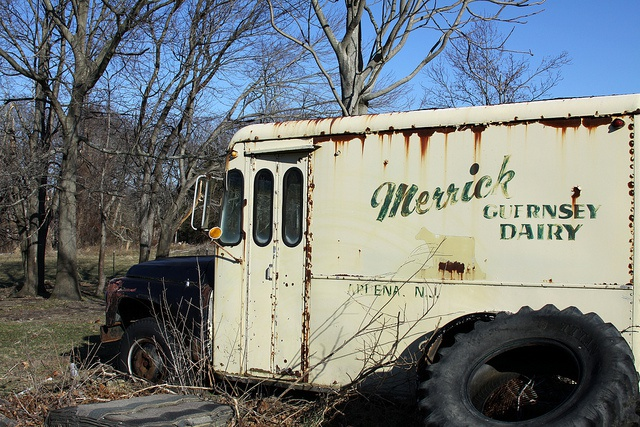Describe the objects in this image and their specific colors. I can see a truck in blue, beige, black, and darkgray tones in this image. 